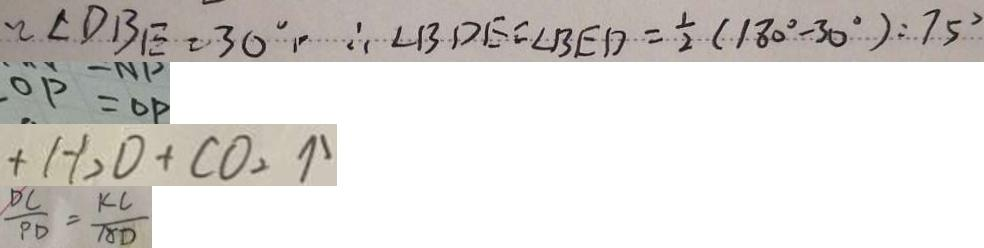<formula> <loc_0><loc_0><loc_500><loc_500>\angle D B E = 3 0 ^ { \circ } , \therefore \angle B D E = \angle B E D = \frac { 1 } { 2 } ( 1 8 0 ^ { \circ } - 3 0 ^ { \circ } ) : 7 5 ^ { \circ } 
 O P = O P 
 + H _ { 2 } D + C O _ { 2 } \uparrow 
 \frac { D C } { P D } = \frac { K C } { A D }</formula> 